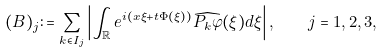<formula> <loc_0><loc_0><loc_500><loc_500>( B ) _ { j } \colon = \sum _ { k \in I _ { j } } \left | \int _ { \mathbb { R } } e ^ { i ( x \xi + t \Phi ( \xi ) ) } \widehat { P _ { k } \varphi } ( \xi ) d \xi \right | , \quad j = 1 , 2 , 3 ,</formula> 